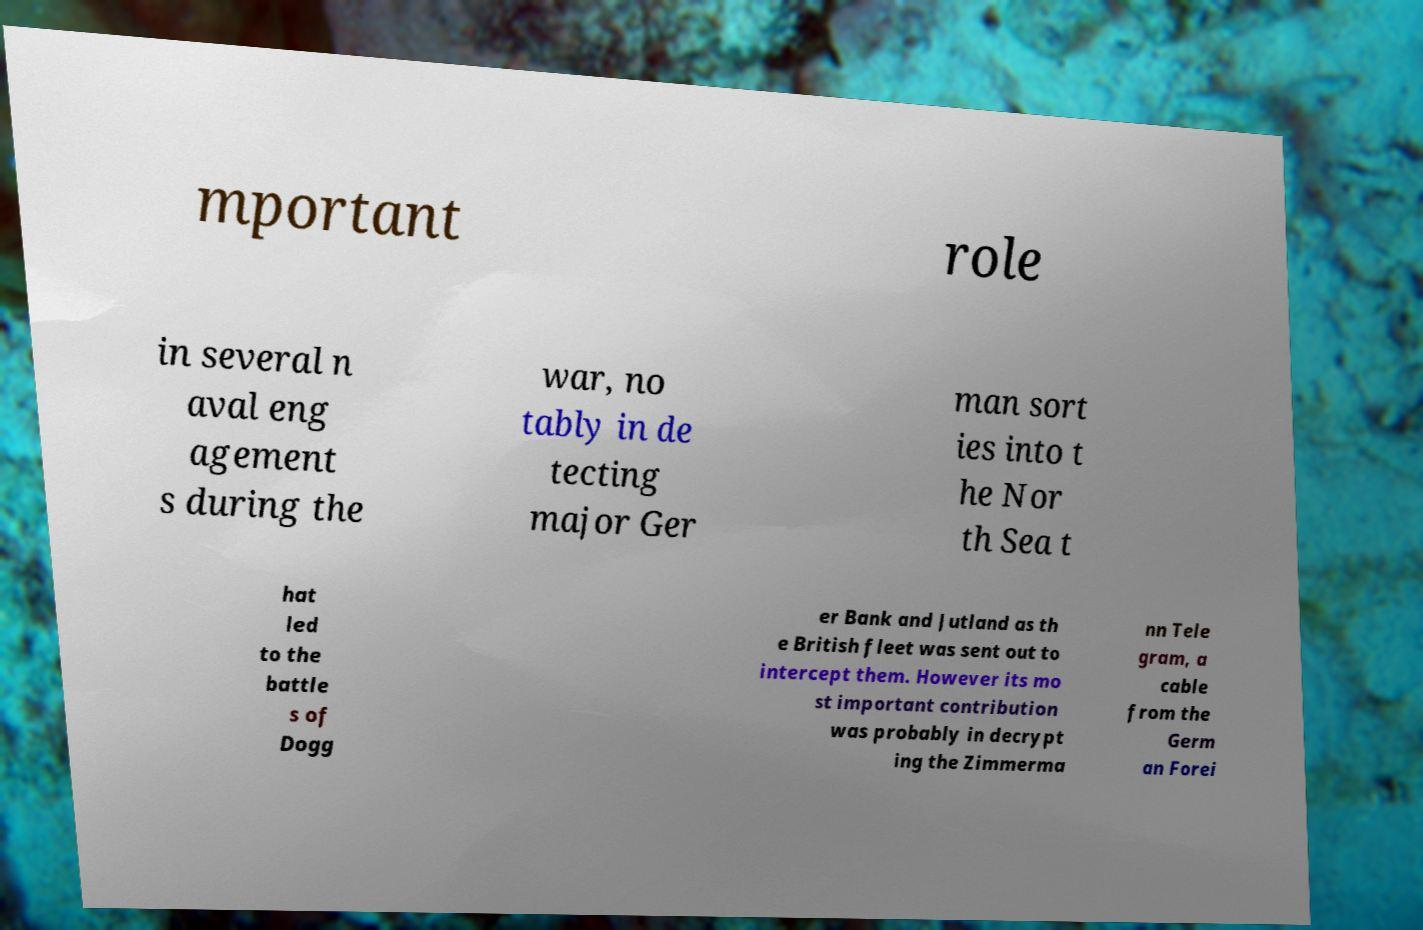Could you assist in decoding the text presented in this image and type it out clearly? mportant role in several n aval eng agement s during the war, no tably in de tecting major Ger man sort ies into t he Nor th Sea t hat led to the battle s of Dogg er Bank and Jutland as th e British fleet was sent out to intercept them. However its mo st important contribution was probably in decrypt ing the Zimmerma nn Tele gram, a cable from the Germ an Forei 